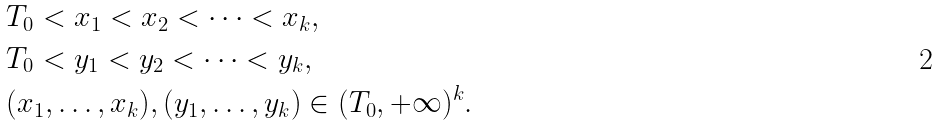Convert formula to latex. <formula><loc_0><loc_0><loc_500><loc_500>& T _ { 0 } < x _ { 1 } < x _ { 2 } < \dots < x _ { k } , \\ & T _ { 0 } < y _ { 1 } < y _ { 2 } < \dots < y _ { k } , \\ & ( x _ { 1 } , \dots , x _ { k } ) , ( y _ { 1 } , \dots , y _ { k } ) \in ( T _ { 0 } , + \infty ) ^ { k } .</formula> 